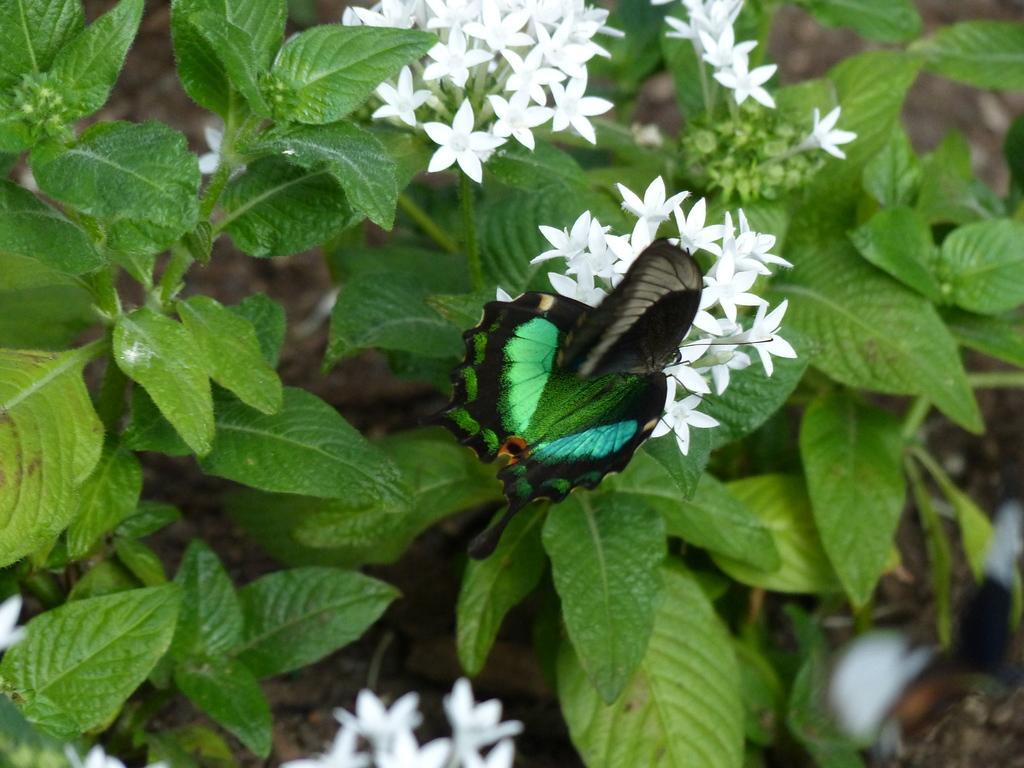Describe this image in one or two sentences. In this image we can see flowers on stems. On the flowers we can see a butterfly. 